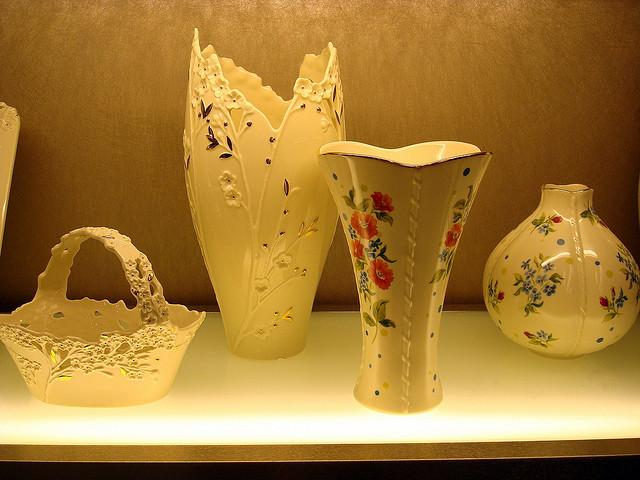How many vases have a handle on them?
Concise answer only. 1. What is the countertop made out of?
Quick response, please. Wood. How many vases are in the picture?
Keep it brief. 3. 